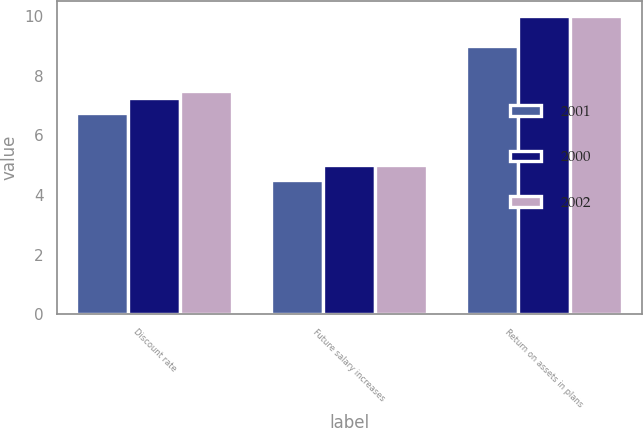Convert chart to OTSL. <chart><loc_0><loc_0><loc_500><loc_500><stacked_bar_chart><ecel><fcel>Discount rate<fcel>Future salary increases<fcel>Return on assets in plans<nl><fcel>2001<fcel>6.75<fcel>4.5<fcel>9<nl><fcel>2000<fcel>7.25<fcel>5<fcel>10<nl><fcel>2002<fcel>7.5<fcel>5<fcel>10<nl></chart> 